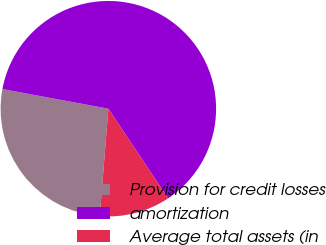Convert chart. <chart><loc_0><loc_0><loc_500><loc_500><pie_chart><fcel>Provision for credit losses<fcel>amortization<fcel>Average total assets (in<nl><fcel>26.65%<fcel>62.74%<fcel>10.62%<nl></chart> 